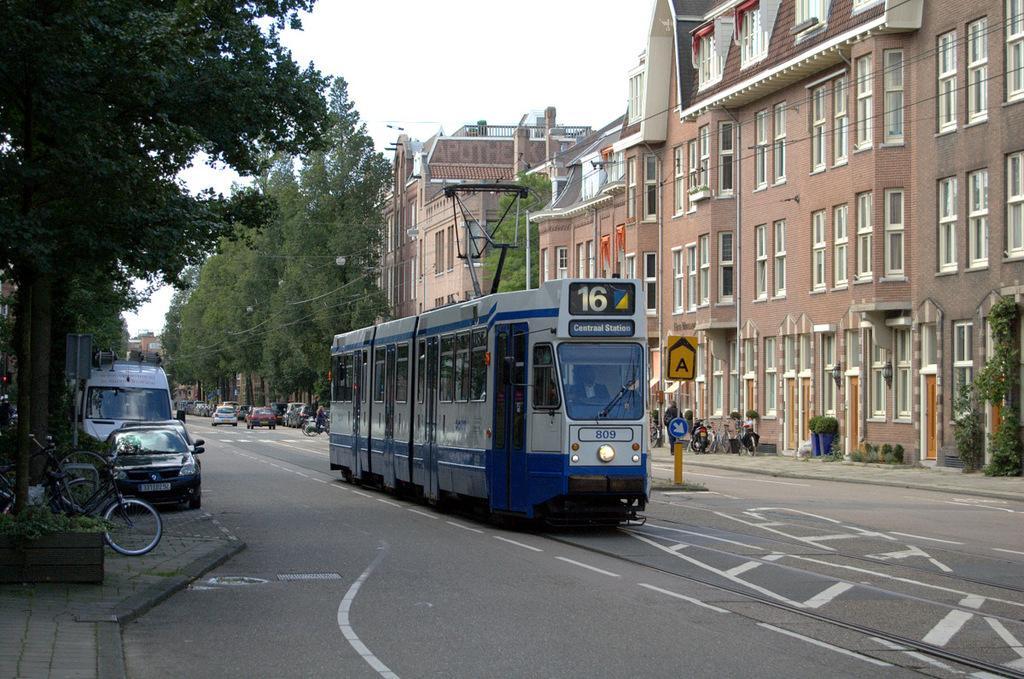Describe this image in one or two sentences. There is an electrical bus on the road as we can see in the middle of this image. There are some buildings and trees in the background. There are some cars and bicycles on the left side of this image and right side of this image as well. 